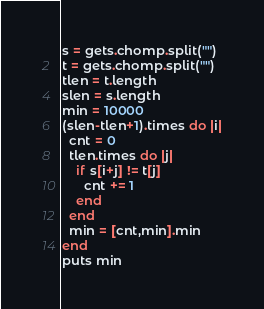Convert code to text. <code><loc_0><loc_0><loc_500><loc_500><_Ruby_>s = gets.chomp.split("")
t = gets.chomp.split("")
tlen = t.length
slen = s.length
min = 10000
(slen-tlen+1).times do |i|
  cnt = 0
  tlen.times do |j|
    if s[i+j] != t[j]
      cnt += 1
    end
  end
  min = [cnt,min].min
end
puts min</code> 